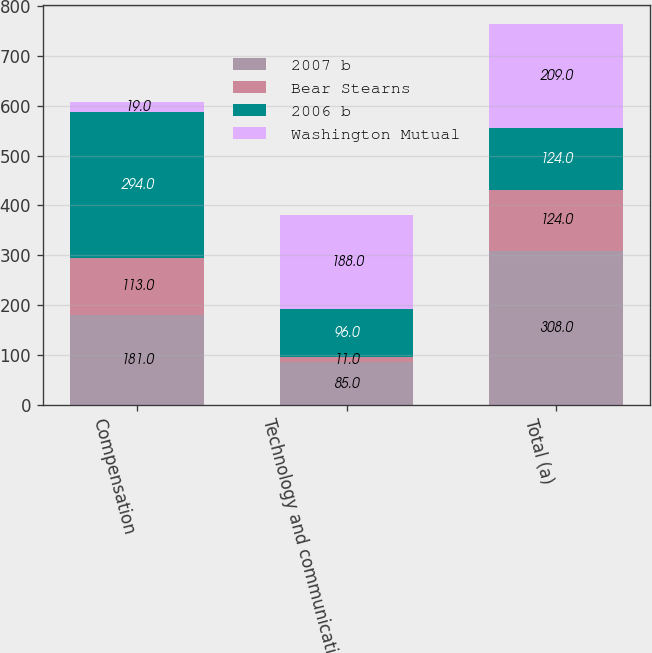Convert chart to OTSL. <chart><loc_0><loc_0><loc_500><loc_500><stacked_bar_chart><ecel><fcel>Compensation<fcel>Technology and communications<fcel>Total (a)<nl><fcel>2007 b<fcel>181<fcel>85<fcel>308<nl><fcel>Bear Stearns<fcel>113<fcel>11<fcel>124<nl><fcel>2006 b<fcel>294<fcel>96<fcel>124<nl><fcel>Washington Mutual<fcel>19<fcel>188<fcel>209<nl></chart> 